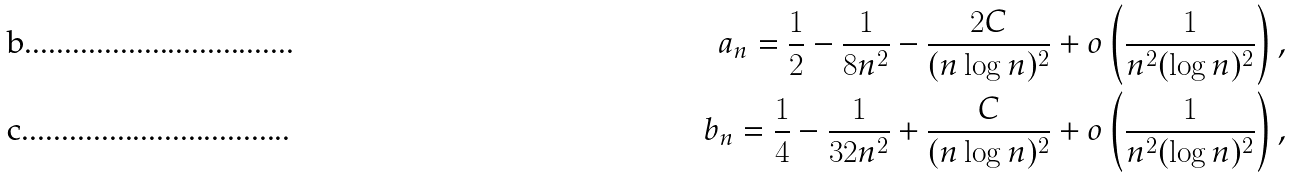Convert formula to latex. <formula><loc_0><loc_0><loc_500><loc_500>a _ { n } = \frac { 1 } { 2 } - \frac { 1 } { 8 n ^ { 2 } } - \frac { 2 C } { ( n \log n ) ^ { 2 } } + o \left ( \frac { 1 } { n ^ { 2 } ( \log n ) ^ { 2 } } \right ) , \\ b _ { n } = \frac { 1 } { 4 } - \frac { 1 } { 3 2 n ^ { 2 } } + \frac { C } { ( n \log n ) ^ { 2 } } + o \left ( \frac { 1 } { n ^ { 2 } ( \log n ) ^ { 2 } } \right ) ,</formula> 